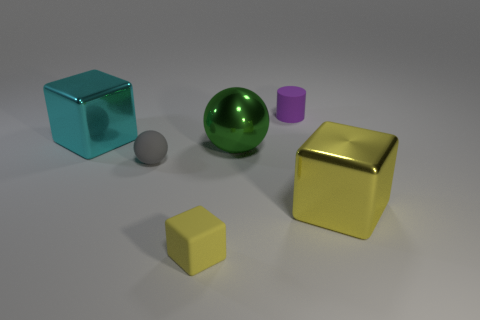Subtract all large blocks. How many blocks are left? 1 Subtract all red cylinders. How many yellow blocks are left? 2 Add 1 large green metal objects. How many objects exist? 7 Add 6 large cyan metallic things. How many large cyan metallic things exist? 7 Subtract 0 brown cylinders. How many objects are left? 6 Subtract all cylinders. How many objects are left? 5 Subtract all large yellow shiny cubes. Subtract all metal blocks. How many objects are left? 3 Add 2 matte cylinders. How many matte cylinders are left? 3 